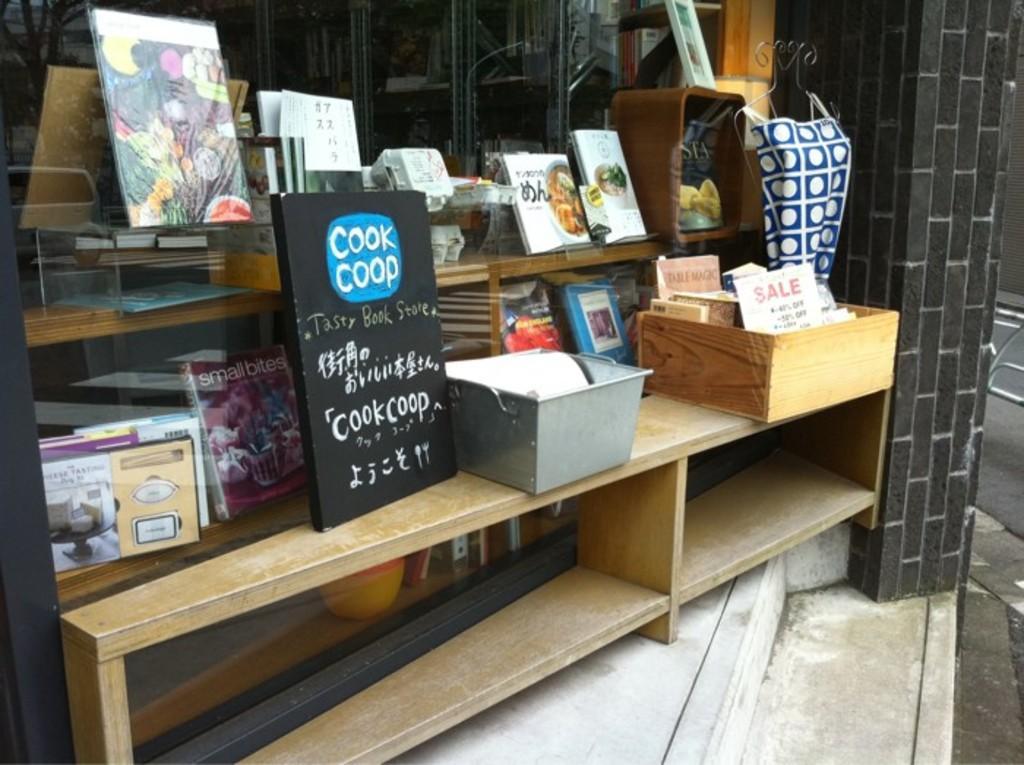Can you describe this image briefly? On a table there are books, black board and boxes. 